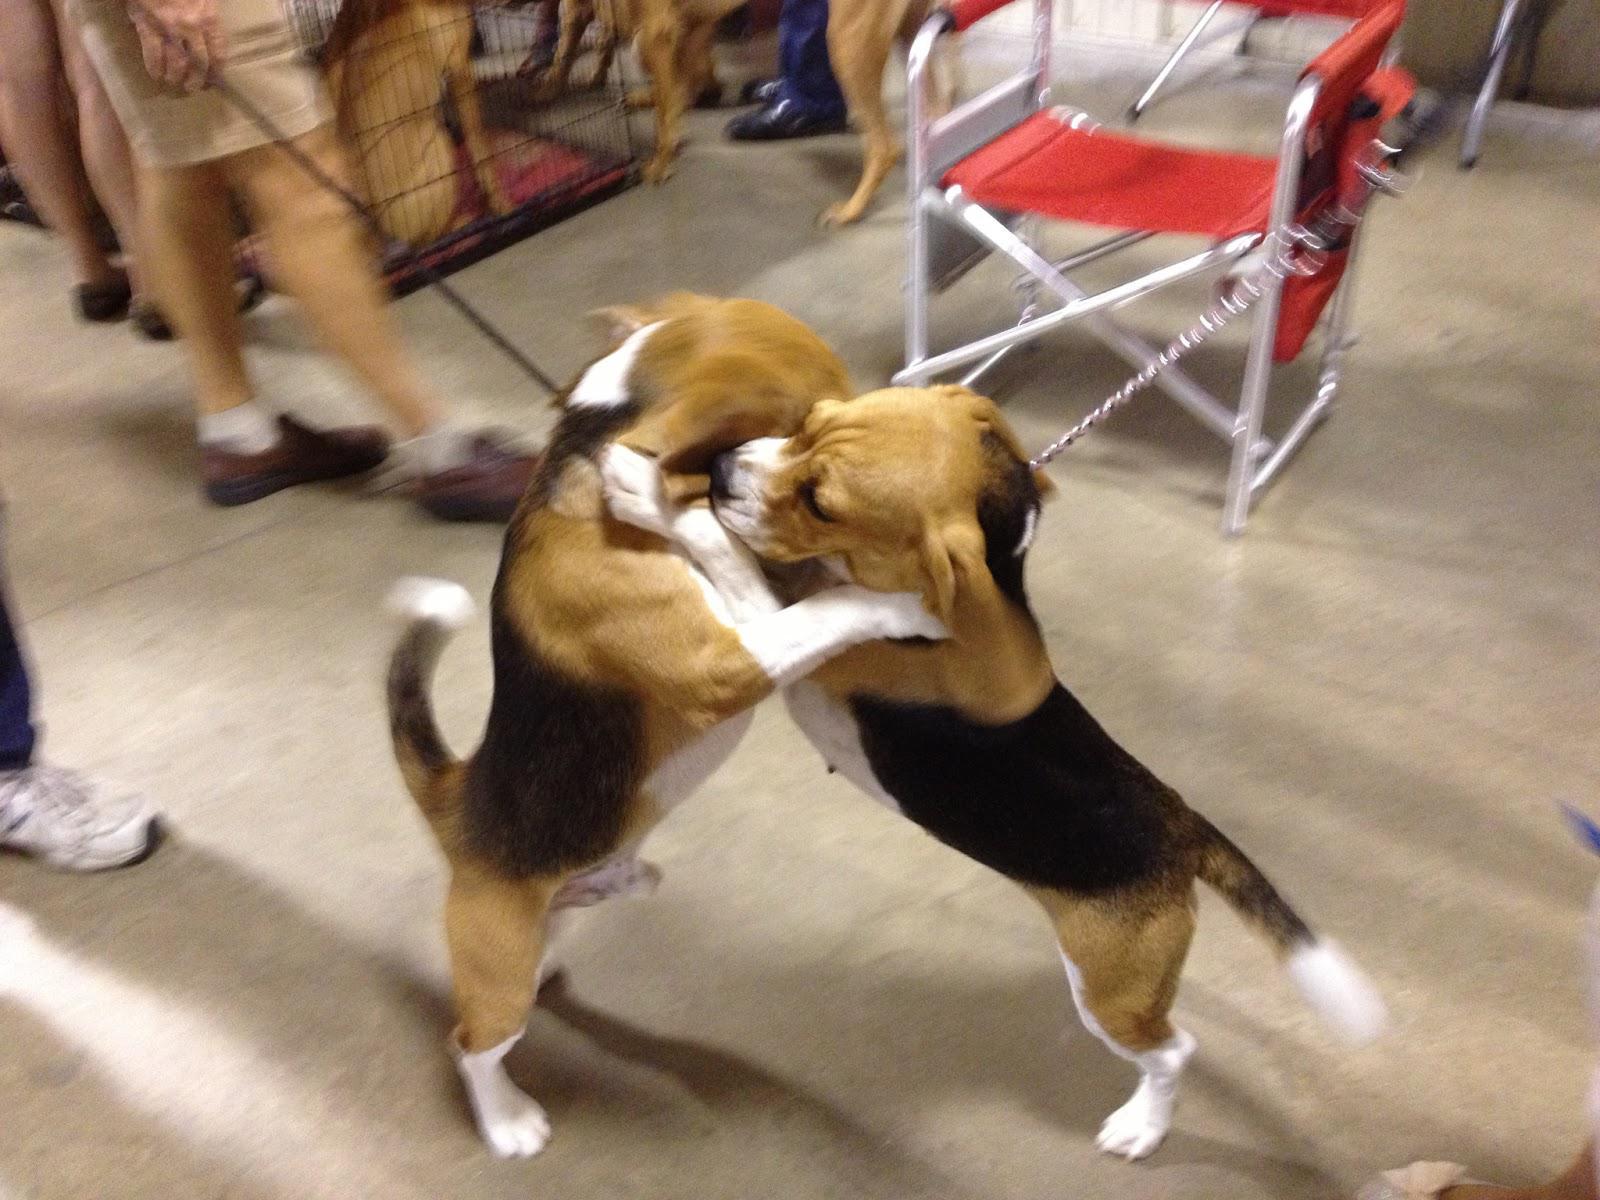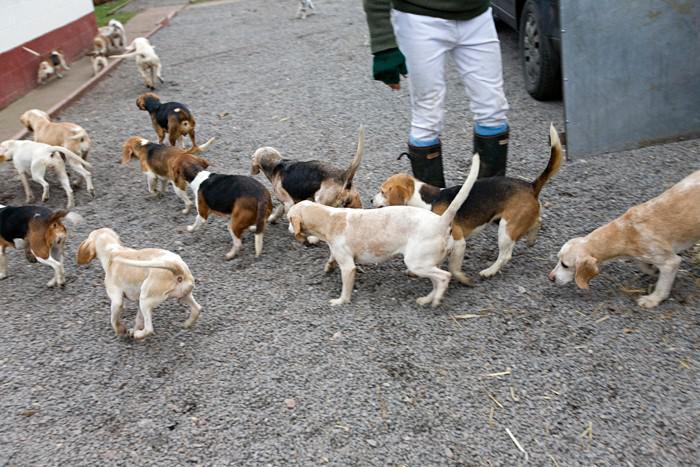The first image is the image on the left, the second image is the image on the right. Given the left and right images, does the statement "There are two dog figurines on the left." hold true? Answer yes or no. No. The first image is the image on the left, the second image is the image on the right. Assess this claim about the two images: "There is only one real dog in total.". Correct or not? Answer yes or no. No. 